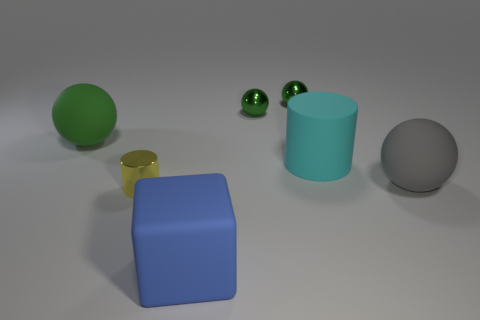Are there any big spheres made of the same material as the blue object? Yes, there is a larger sphere in the back left of the image that appears to share the same matte texture and solid color characteristic as the blue cube in the foreground, suggesting that they might be made of similar materials. 